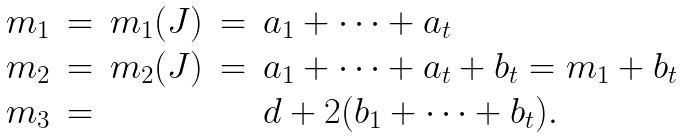Convert formula to latex. <formula><loc_0><loc_0><loc_500><loc_500>\begin{array} { r c c c l } m _ { 1 } & = & m _ { 1 } ( J ) & = & a _ { 1 } + \dots + a _ { t } \\ m _ { 2 } & = & m _ { 2 } ( J ) & = & a _ { 1 } + \dots + a _ { t } + b _ { t } = m _ { 1 } + b _ { t } \\ m _ { 3 } & = & & & d + 2 ( b _ { 1 } + \dots + b _ { t } ) . \end{array}</formula> 